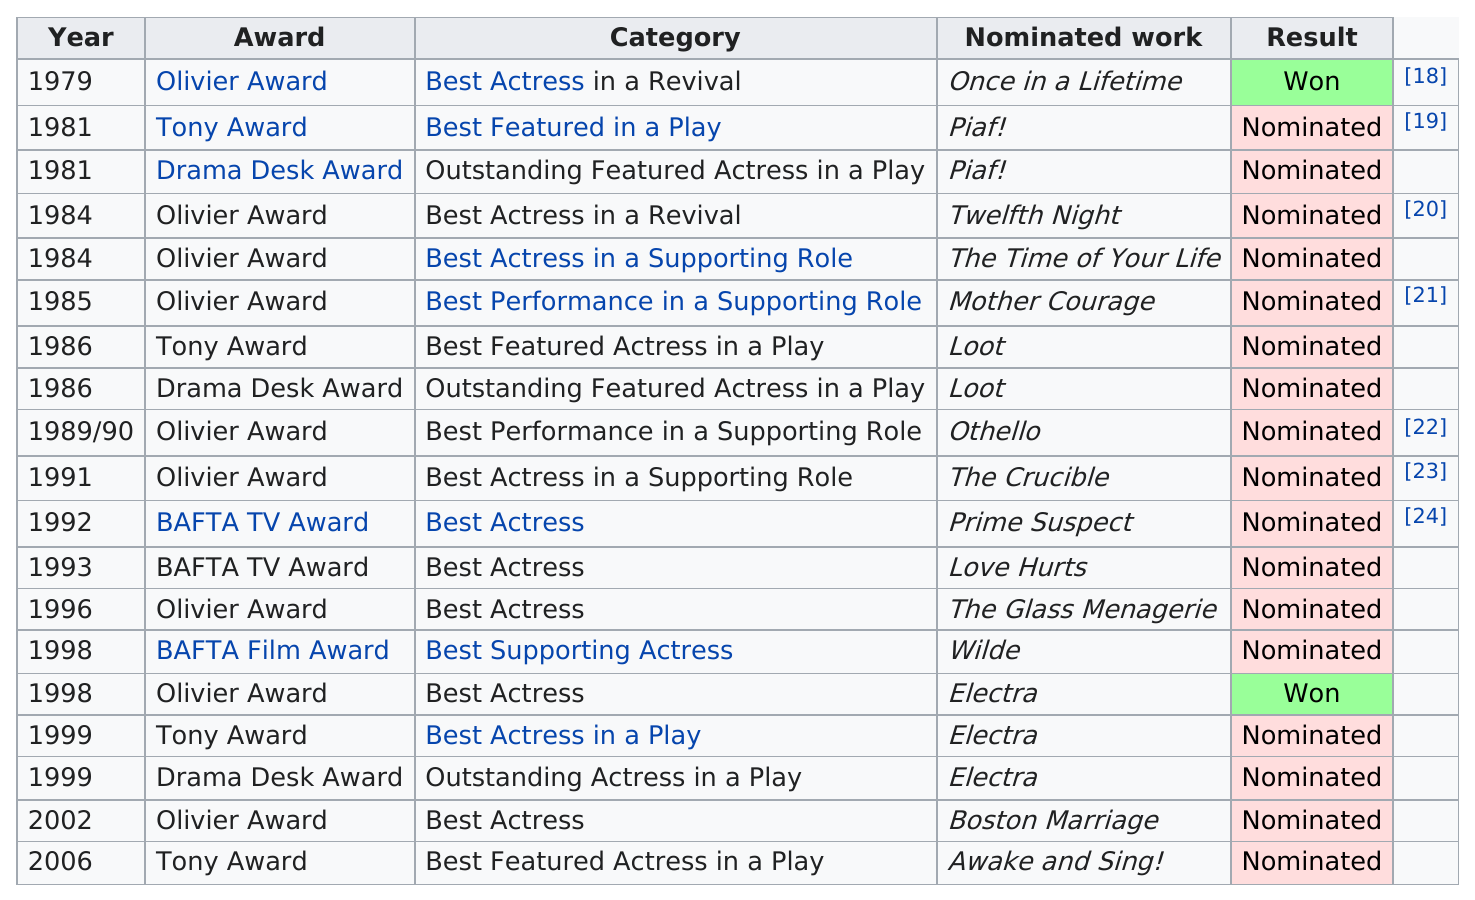Give some essential details in this illustration. I have won the prestigious award for Best Actress in a Revival, which I consider to be a once-in-a-lifetime achievement. In 1986, Patti LuPone was nominated for a Best Featured Actress Tony Award for her performance in the play "Loot," which was a comedy about two young thieves who plan to rob a wealthy man's funeral. In 1992, Prime Suspect was nominated for a BAFTA TV Award. Wanamaker was nominated for Best Actress in a Revival for Twelfth Night in 1984. Wanamaker was nominated for Best Featured Actor in a Play in 1981 for his performance in "Piaf!. 